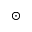<formula> <loc_0><loc_0><loc_500><loc_500>_ { \odot }</formula> 